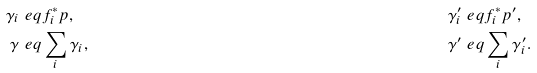Convert formula to latex. <formula><loc_0><loc_0><loc_500><loc_500>\gamma _ { i } & \ e q f _ { i } ^ { * } p , & \gamma _ { i } ^ { \prime } & \ e q f _ { i } ^ { * } p ^ { \prime } , \\ \gamma & \ e q \sum _ { i } \gamma _ { i } , & \gamma ^ { \prime } & \ e q \sum _ { i } \gamma _ { i } ^ { \prime } .</formula> 